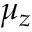Convert formula to latex. <formula><loc_0><loc_0><loc_500><loc_500>\mu _ { z }</formula> 